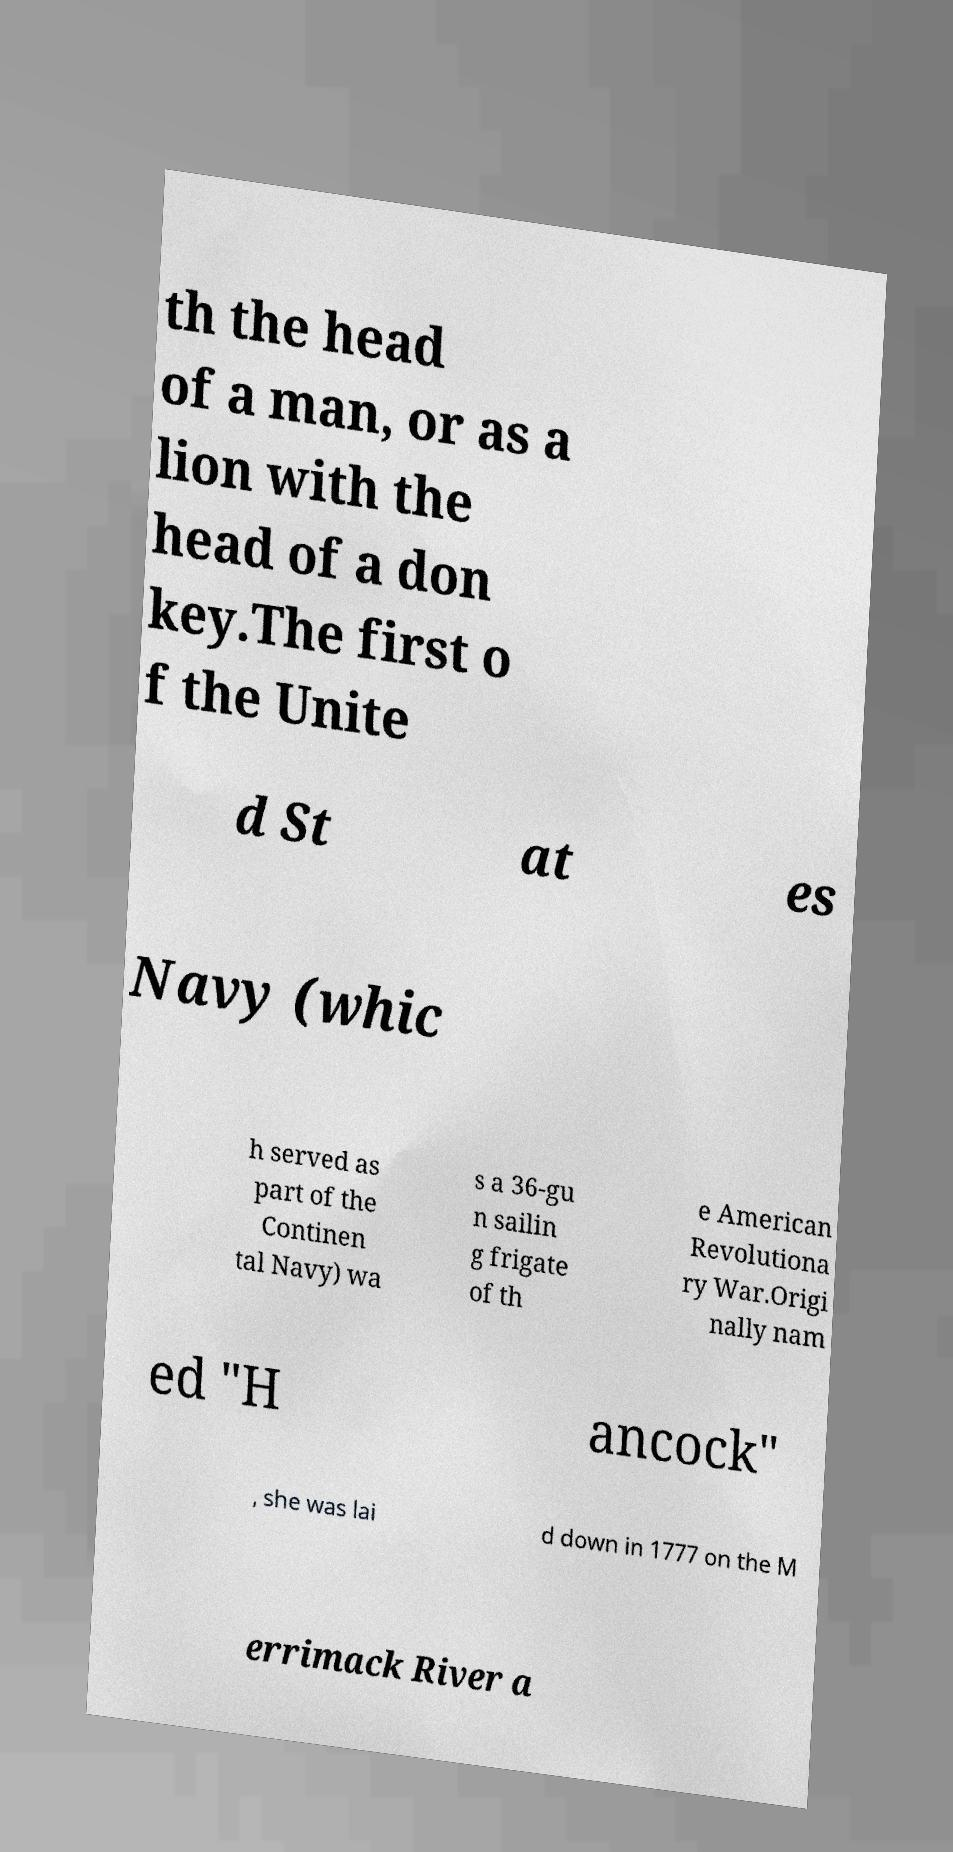Could you extract and type out the text from this image? th the head of a man, or as a lion with the head of a don key.The first o f the Unite d St at es Navy (whic h served as part of the Continen tal Navy) wa s a 36-gu n sailin g frigate of th e American Revolutiona ry War.Origi nally nam ed "H ancock" , she was lai d down in 1777 on the M errimack River a 